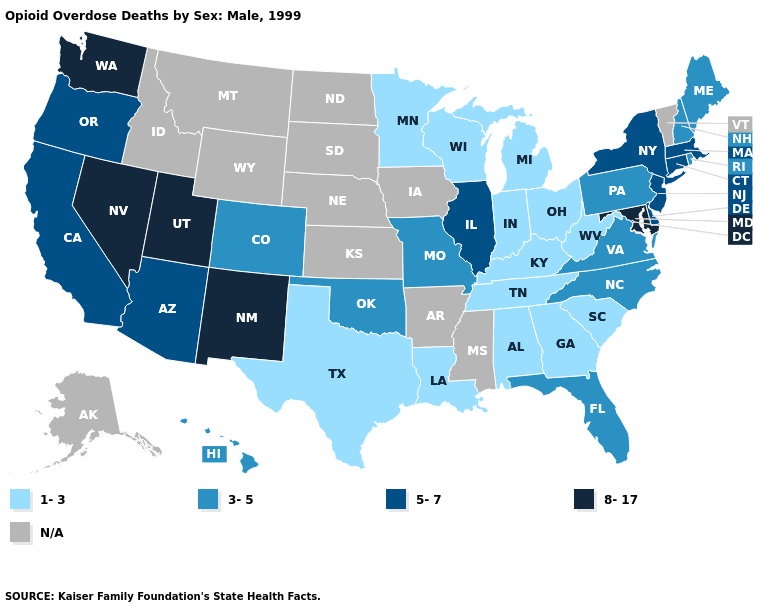Among the states that border Mississippi , which have the highest value?
Give a very brief answer. Alabama, Louisiana, Tennessee. What is the value of Vermont?
Answer briefly. N/A. Among the states that border Tennessee , which have the lowest value?
Be succinct. Alabama, Georgia, Kentucky. Among the states that border Kansas , which have the highest value?
Be succinct. Colorado, Missouri, Oklahoma. What is the lowest value in the MidWest?
Keep it brief. 1-3. What is the lowest value in the USA?
Keep it brief. 1-3. What is the lowest value in states that border Michigan?
Be succinct. 1-3. Which states have the lowest value in the USA?
Keep it brief. Alabama, Georgia, Indiana, Kentucky, Louisiana, Michigan, Minnesota, Ohio, South Carolina, Tennessee, Texas, West Virginia, Wisconsin. Name the states that have a value in the range 1-3?
Concise answer only. Alabama, Georgia, Indiana, Kentucky, Louisiana, Michigan, Minnesota, Ohio, South Carolina, Tennessee, Texas, West Virginia, Wisconsin. Does Massachusetts have the lowest value in the Northeast?
Answer briefly. No. What is the highest value in the West ?
Give a very brief answer. 8-17. Name the states that have a value in the range 8-17?
Concise answer only. Maryland, Nevada, New Mexico, Utah, Washington. What is the value of Florida?
Keep it brief. 3-5. What is the highest value in states that border Maine?
Be succinct. 3-5. Name the states that have a value in the range N/A?
Short answer required. Alaska, Arkansas, Idaho, Iowa, Kansas, Mississippi, Montana, Nebraska, North Dakota, South Dakota, Vermont, Wyoming. 